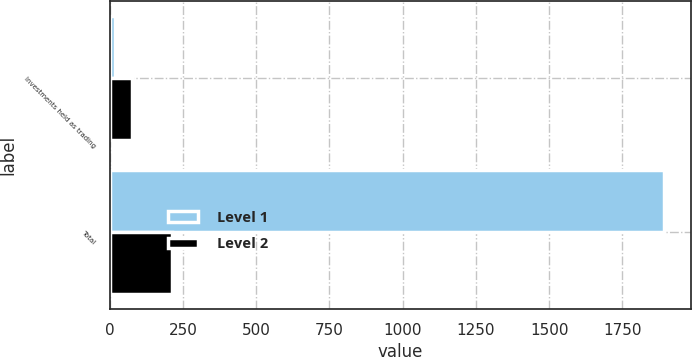Convert chart. <chart><loc_0><loc_0><loc_500><loc_500><stacked_bar_chart><ecel><fcel>Investments held as trading<fcel>Total<nl><fcel>Level 1<fcel>18.1<fcel>1891<nl><fcel>Level 2<fcel>77.2<fcel>213.2<nl></chart> 